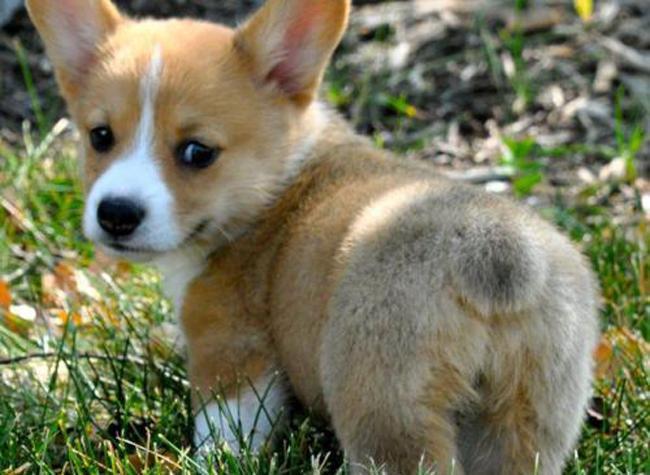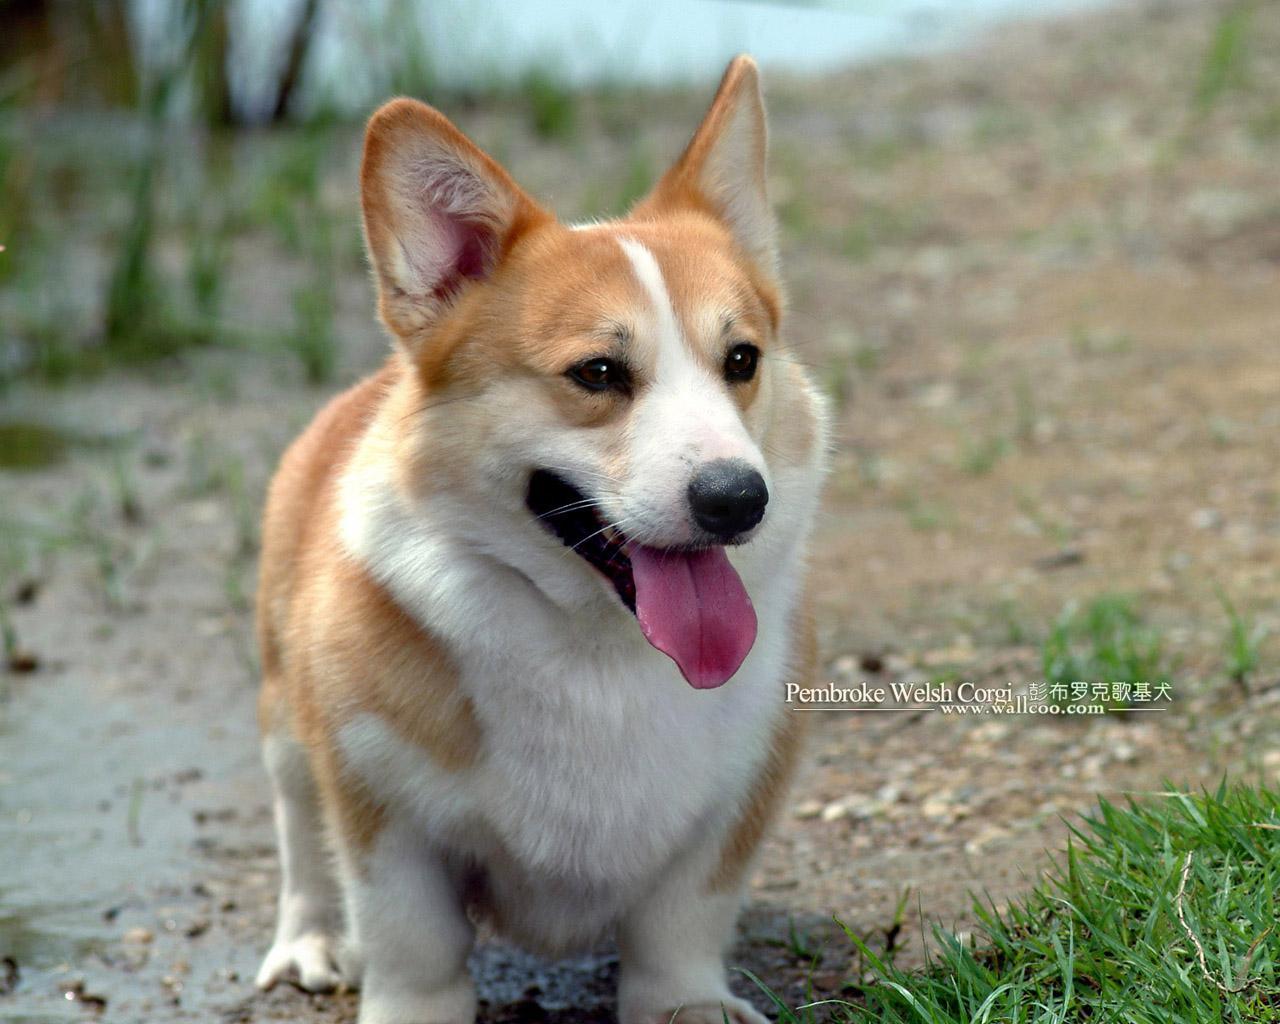The first image is the image on the left, the second image is the image on the right. Evaluate the accuracy of this statement regarding the images: "At least one dog is sitting on its hind legs in the pair of images.". Is it true? Answer yes or no. No. The first image is the image on the left, the second image is the image on the right. Analyze the images presented: Is the assertion "Each image contains exactly one corgi dog, and no dog has its rear-end facing the camera." valid? Answer yes or no. No. 